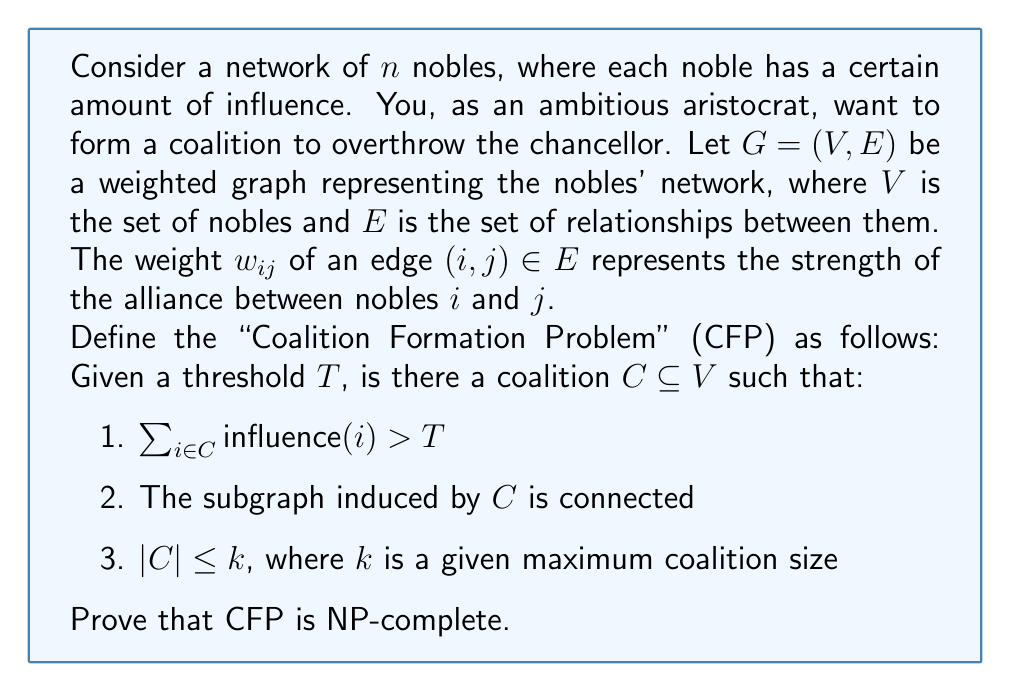Help me with this question. To prove that the Coalition Formation Problem (CFP) is NP-complete, we need to show that it is both in NP and NP-hard.

1. CFP is in NP:
   We can verify a solution in polynomial time. Given a coalition $C$, we can:
   a) Sum the influence of members in $C$ and compare to $T$ in $O(|C|)$ time.
   b) Check connectivity of the subgraph induced by $C$ using BFS or DFS in $O(|C|^2)$ time.
   c) Verify that $|C| \leq k$ in $O(1)$ time.
   Thus, the problem is in NP.

2. CFP is NP-hard:
   We will prove this by reduction from the Connected Vertex Cover (CVC) problem, which is known to be NP-complete.

   CVC Problem: Given a graph $G' = (V', E')$ and an integer $k'$, is there a vertex cover $C'$ of size at most $k'$ such that the subgraph induced by $C'$ is connected?

   Reduction from CVC to CFP:
   a) Set $G = G'$
   b) Set $influence(v) = 1$ for all $v \in V$
   c) Set $w_{ij} = 1$ for all $(i,j) \in E$
   d) Set $T = |V'| - k'$
   e) Set $k = k'$

   Now, we claim that there exists a solution to CVC if and only if there exists a solution to CFP.

   ($\Rightarrow$) If $C'$ is a solution to CVC:
   - $C'$ is connected in $G'$, so it's connected in $G$.
   - $|C'| \leq k' = k$
   - The sum of influences in $C'$ is $|C'| \leq k'$, so the sum of influences in $V \setminus C'$ is $\geq |V'| - k' = T$

   ($\Leftarrow$) If $C$ is a solution to CFP:
   - $C$ is connected in $G$
   - $|C| \leq k = k'$
   - The sum of influences in $C$ is $> T = |V'| - k'$, so $|C| > |V'| - k'$, which means $|V \setminus C| < k'$
   - $V \setminus C$ forms a vertex cover in $G'$ of size $< k'$

   This reduction can be performed in polynomial time, proving that CFP is NP-hard.

Since CFP is both in NP and NP-hard, it is NP-complete.
Answer: The Coalition Formation Problem (CFP) is NP-complete. 